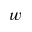Convert formula to latex. <formula><loc_0><loc_0><loc_500><loc_500>w</formula> 